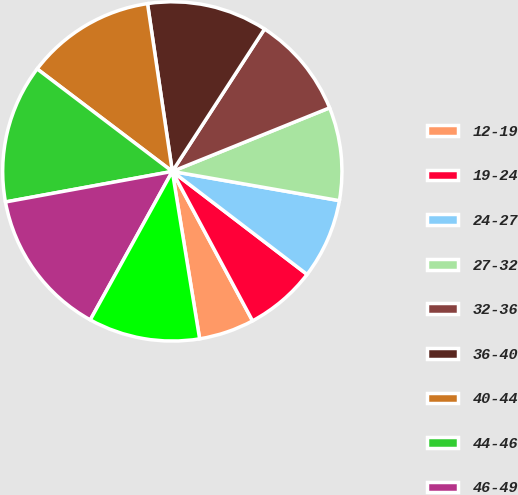Convert chart. <chart><loc_0><loc_0><loc_500><loc_500><pie_chart><fcel>12-19<fcel>19-24<fcel>24-27<fcel>27-32<fcel>32-36<fcel>36-40<fcel>40-44<fcel>44-46<fcel>46-49<fcel>0-49<nl><fcel>5.27%<fcel>6.77%<fcel>7.63%<fcel>8.87%<fcel>9.74%<fcel>11.48%<fcel>12.34%<fcel>13.21%<fcel>14.08%<fcel>10.61%<nl></chart> 